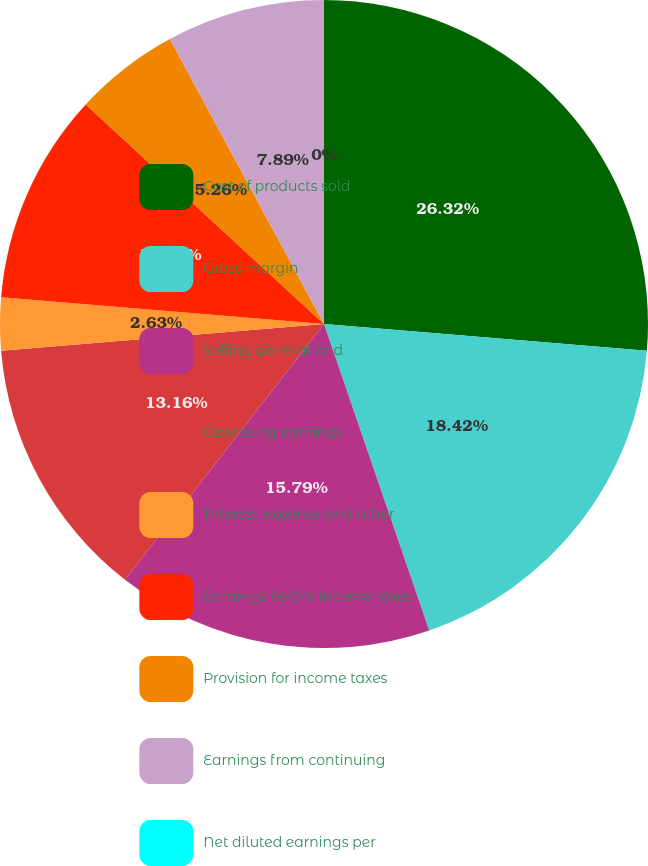Convert chart to OTSL. <chart><loc_0><loc_0><loc_500><loc_500><pie_chart><fcel>Cost of products sold<fcel>Gross margin<fcel>Selling general and<fcel>Operating earnings<fcel>Interest expense and other<fcel>Earnings before income taxes<fcel>Provision for income taxes<fcel>Earnings from continuing<fcel>Net diluted earnings per<nl><fcel>26.31%<fcel>18.42%<fcel>15.79%<fcel>13.16%<fcel>2.63%<fcel>10.53%<fcel>5.26%<fcel>7.89%<fcel>0.0%<nl></chart> 